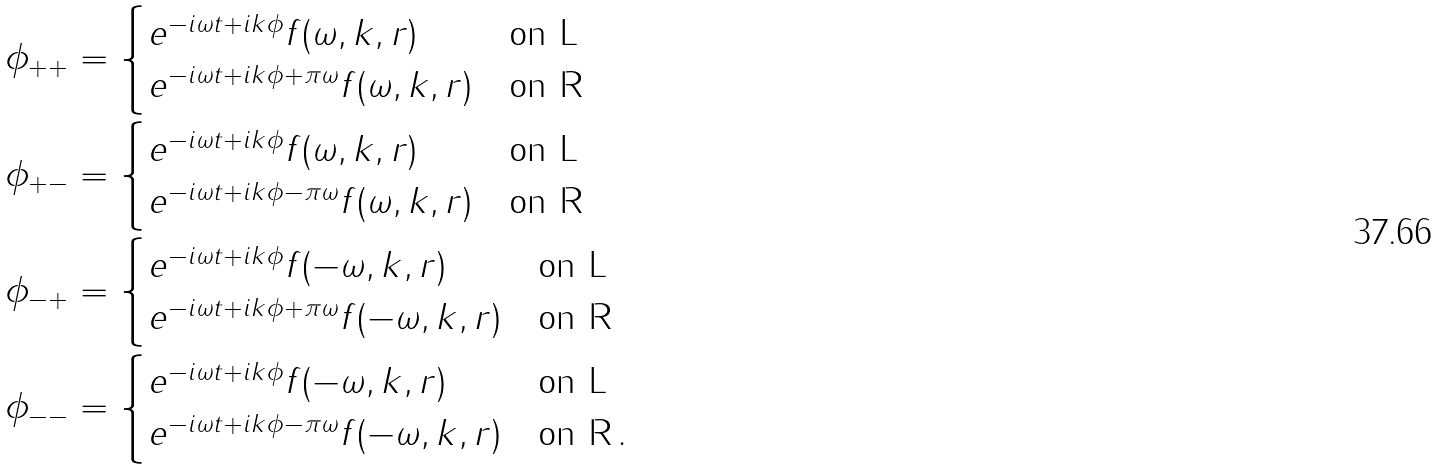Convert formula to latex. <formula><loc_0><loc_0><loc_500><loc_500>\phi _ { + + } & = \begin{cases} e ^ { - i \omega t + i k \phi } f ( \omega , k , r ) & \text {on L} \\ e ^ { - i \omega t + i k \phi + \pi \omega } f ( \omega , k , r ) & \text {on R} \end{cases} \\ \phi _ { + - } & = \begin{cases} e ^ { - i \omega t + i k \phi } f ( \omega , k , r ) & \text {on L} \\ e ^ { - i \omega t + i k \phi - \pi \omega } f ( \omega , k , r ) & \text {on R} \end{cases} \\ \phi _ { - + } & = \begin{cases} e ^ { - i \omega t + i k \phi } f ( - \omega , k , r ) & \text {on L} \\ e ^ { - i \omega t + i k \phi + \pi \omega } f ( - \omega , k , r ) & \text {on R} \end{cases} \\ \phi _ { - - } & = \begin{cases} e ^ { - i \omega t + i k \phi } f ( - \omega , k , r ) & \text {on L} \\ e ^ { - i \omega t + i k \phi - \pi \omega } f ( - \omega , k , r ) & \text {on R} \, . \end{cases} \\</formula> 